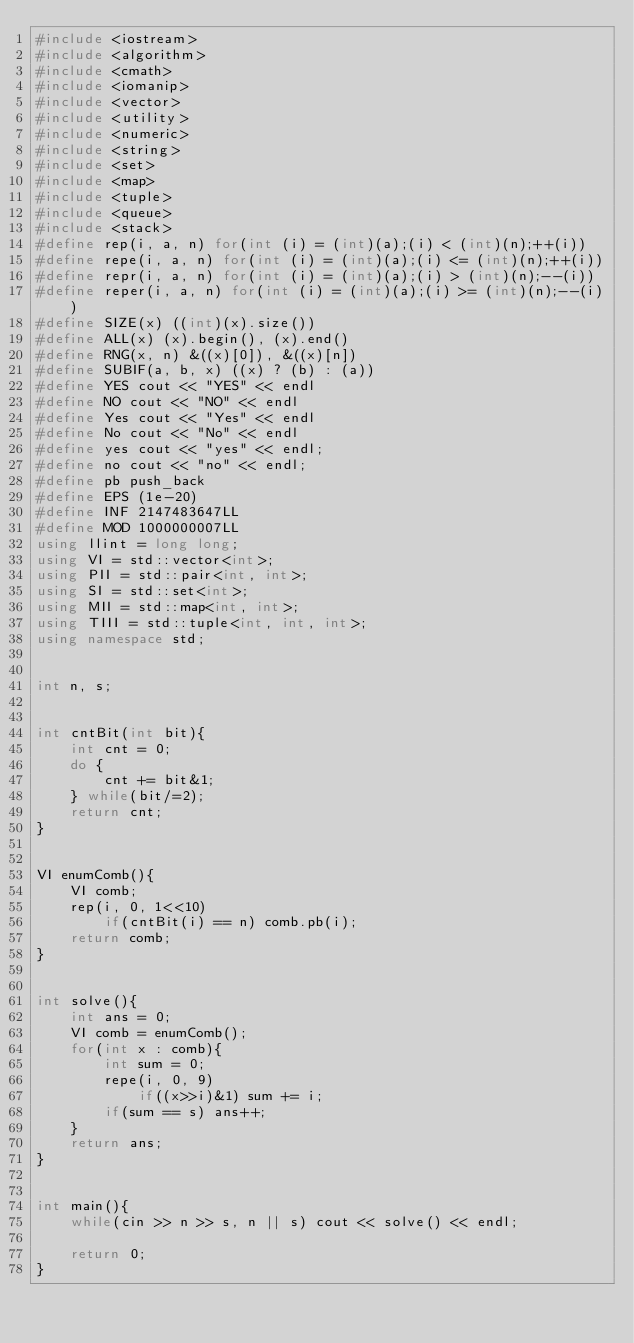Convert code to text. <code><loc_0><loc_0><loc_500><loc_500><_C++_>#include <iostream>
#include <algorithm>
#include <cmath>
#include <iomanip>
#include <vector>
#include <utility>
#include <numeric>
#include <string>
#include <set>
#include <map>
#include <tuple>
#include <queue>
#include <stack>
#define rep(i, a, n) for(int (i) = (int)(a);(i) < (int)(n);++(i))
#define repe(i, a, n) for(int (i) = (int)(a);(i) <= (int)(n);++(i))
#define repr(i, a, n) for(int (i) = (int)(a);(i) > (int)(n);--(i))
#define reper(i, a, n) for(int (i) = (int)(a);(i) >= (int)(n);--(i))
#define SIZE(x) ((int)(x).size())
#define ALL(x) (x).begin(), (x).end()
#define RNG(x, n) &((x)[0]), &((x)[n])
#define SUBIF(a, b, x) ((x) ? (b) : (a))
#define YES cout << "YES" << endl
#define NO cout << "NO" << endl
#define Yes cout << "Yes" << endl
#define No cout << "No" << endl
#define yes cout << "yes" << endl;
#define no cout << "no" << endl;
#define pb push_back
#define EPS (1e-20)
#define INF 2147483647LL
#define MOD 1000000007LL
using llint = long long;
using VI = std::vector<int>;
using PII = std::pair<int, int>;
using SI = std::set<int>;
using MII = std::map<int, int>;
using TIII = std::tuple<int, int, int>;
using namespace std;


int n, s;


int cntBit(int bit){
	int cnt = 0;
	do {
		cnt += bit&1;
	} while(bit/=2);
	return cnt;
}


VI enumComb(){
	VI comb;
	rep(i, 0, 1<<10)
		if(cntBit(i) == n) comb.pb(i);
	return comb;
}


int solve(){
	int ans = 0;
	VI comb = enumComb();
	for(int x : comb){
		int sum = 0;
		repe(i, 0, 9)
			if((x>>i)&1) sum += i;
		if(sum == s) ans++;
	}
	return ans;
}


int main(){
	while(cin >> n >> s, n || s) cout << solve() << endl;

	return 0;
}
</code> 